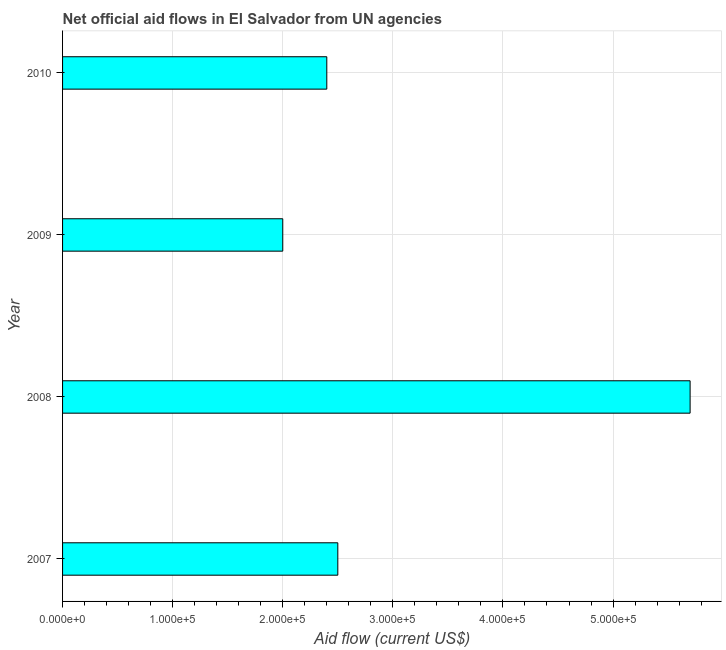Does the graph contain any zero values?
Your answer should be very brief. No. What is the title of the graph?
Offer a very short reply. Net official aid flows in El Salvador from UN agencies. What is the label or title of the X-axis?
Ensure brevity in your answer.  Aid flow (current US$). Across all years, what is the maximum net official flows from un agencies?
Provide a short and direct response. 5.70e+05. Across all years, what is the minimum net official flows from un agencies?
Provide a short and direct response. 2.00e+05. In which year was the net official flows from un agencies maximum?
Keep it short and to the point. 2008. In which year was the net official flows from un agencies minimum?
Your answer should be very brief. 2009. What is the sum of the net official flows from un agencies?
Your response must be concise. 1.26e+06. What is the average net official flows from un agencies per year?
Offer a terse response. 3.15e+05. What is the median net official flows from un agencies?
Provide a short and direct response. 2.45e+05. In how many years, is the net official flows from un agencies greater than 220000 US$?
Your answer should be compact. 3. Do a majority of the years between 2008 and 2009 (inclusive) have net official flows from un agencies greater than 400000 US$?
Your answer should be very brief. No. Is the net official flows from un agencies in 2008 less than that in 2010?
Keep it short and to the point. No. What is the difference between the highest and the second highest net official flows from un agencies?
Offer a terse response. 3.20e+05. What is the difference between the highest and the lowest net official flows from un agencies?
Offer a terse response. 3.70e+05. How many years are there in the graph?
Provide a succinct answer. 4. What is the difference between two consecutive major ticks on the X-axis?
Offer a very short reply. 1.00e+05. What is the Aid flow (current US$) in 2007?
Ensure brevity in your answer.  2.50e+05. What is the Aid flow (current US$) in 2008?
Your response must be concise. 5.70e+05. What is the Aid flow (current US$) of 2010?
Make the answer very short. 2.40e+05. What is the difference between the Aid flow (current US$) in 2007 and 2008?
Keep it short and to the point. -3.20e+05. What is the difference between the Aid flow (current US$) in 2008 and 2009?
Offer a terse response. 3.70e+05. What is the difference between the Aid flow (current US$) in 2008 and 2010?
Offer a very short reply. 3.30e+05. What is the ratio of the Aid flow (current US$) in 2007 to that in 2008?
Provide a succinct answer. 0.44. What is the ratio of the Aid flow (current US$) in 2007 to that in 2009?
Give a very brief answer. 1.25. What is the ratio of the Aid flow (current US$) in 2007 to that in 2010?
Make the answer very short. 1.04. What is the ratio of the Aid flow (current US$) in 2008 to that in 2009?
Make the answer very short. 2.85. What is the ratio of the Aid flow (current US$) in 2008 to that in 2010?
Ensure brevity in your answer.  2.38. What is the ratio of the Aid flow (current US$) in 2009 to that in 2010?
Ensure brevity in your answer.  0.83. 